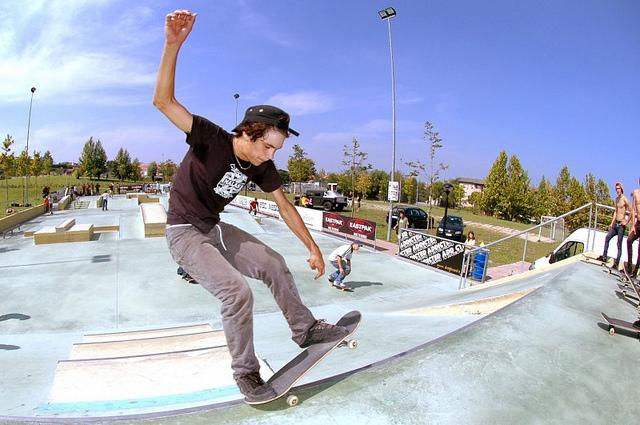What is he standing on?
Write a very short answer. Skateboard. Is the guy performing well?
Short answer required. Yes. Are there lots of spectators?
Give a very brief answer. No. What color is the man's shirt?
Concise answer only. Black. 